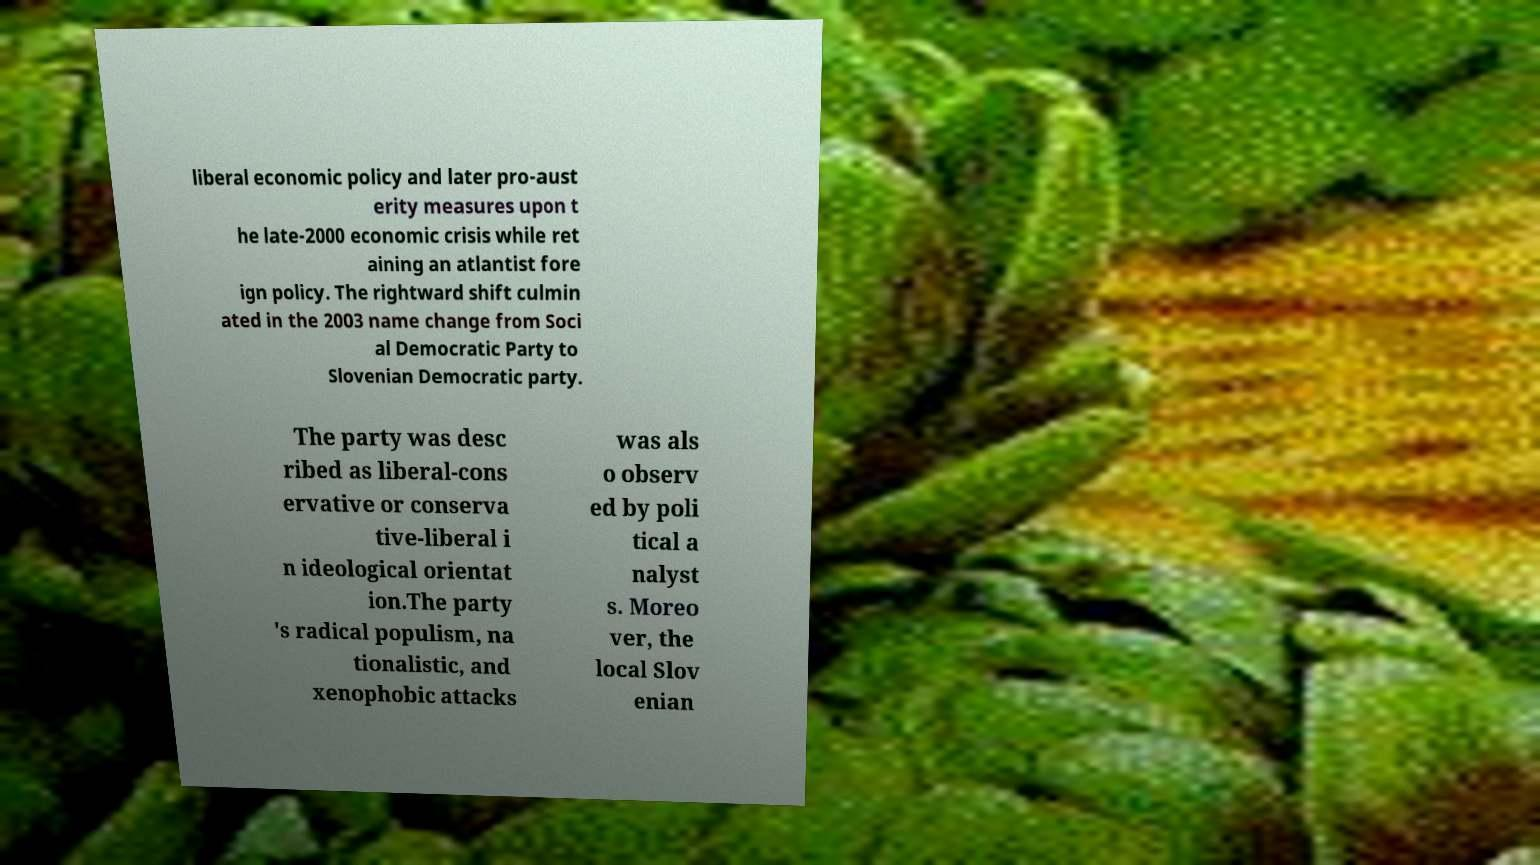What messages or text are displayed in this image? I need them in a readable, typed format. liberal economic policy and later pro-aust erity measures upon t he late-2000 economic crisis while ret aining an atlantist fore ign policy. The rightward shift culmin ated in the 2003 name change from Soci al Democratic Party to Slovenian Democratic party. The party was desc ribed as liberal-cons ervative or conserva tive-liberal i n ideological orientat ion.The party 's radical populism, na tionalistic, and xenophobic attacks was als o observ ed by poli tical a nalyst s. Moreo ver, the local Slov enian 